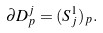<formula> <loc_0><loc_0><loc_500><loc_500>\partial D ^ { j } _ { p } = ( S ^ { 1 } _ { j } ) _ { p } .</formula> 